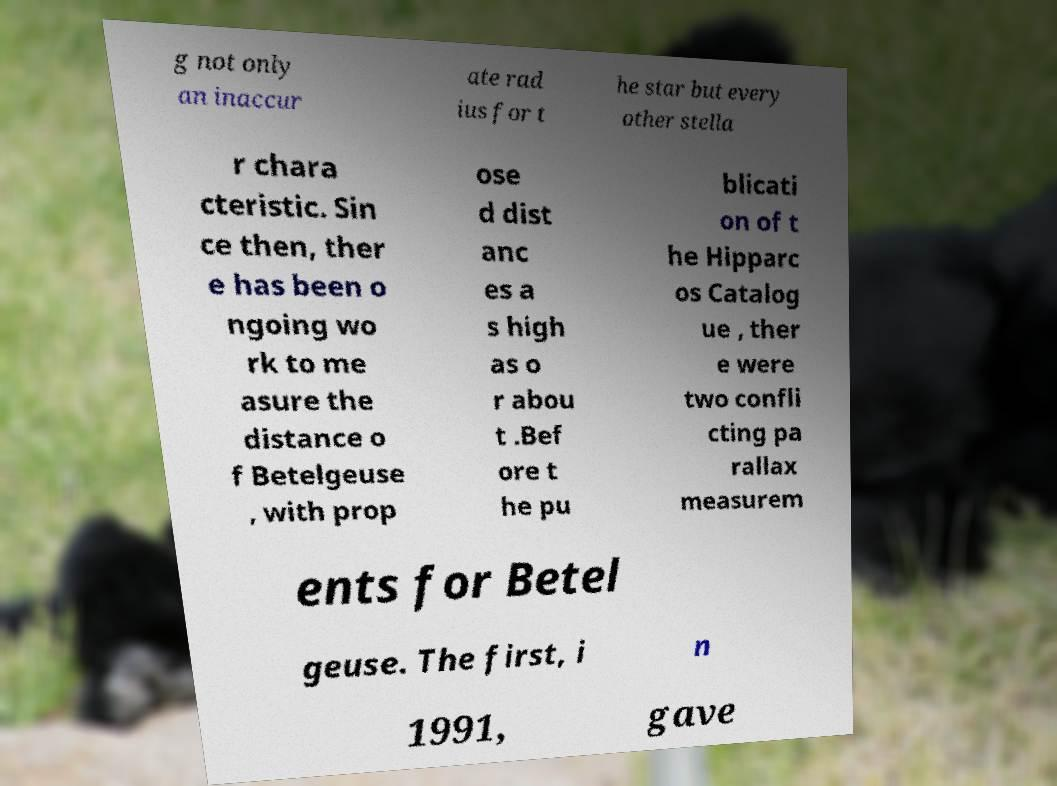For documentation purposes, I need the text within this image transcribed. Could you provide that? g not only an inaccur ate rad ius for t he star but every other stella r chara cteristic. Sin ce then, ther e has been o ngoing wo rk to me asure the distance o f Betelgeuse , with prop ose d dist anc es a s high as o r abou t .Bef ore t he pu blicati on of t he Hipparc os Catalog ue , ther e were two confli cting pa rallax measurem ents for Betel geuse. The first, i n 1991, gave 